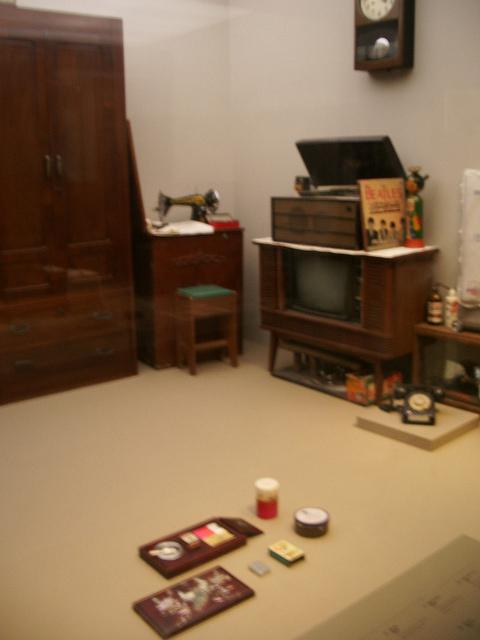What room of the house is this?
Write a very short answer. Living room. Is there a clock on the wall?
Be succinct. Yes. What room is this?
Short answer required. Living room. Is this an office?
Short answer required. No. What year did that style of television fall by the wayside?
Short answer required. 1980. How many bowls are in the picture?
Quick response, please. 1. What kind of scale is that?
Quick response, please. Food. Is there a sewing machine in the room?
Quick response, please. Yes. 